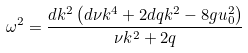<formula> <loc_0><loc_0><loc_500><loc_500>\omega ^ { 2 } = \frac { { d { k ^ { 2 } } \left ( { d \nu { k ^ { 4 } } + 2 d q { k ^ { 2 } } - 8 g u _ { 0 } ^ { 2 } } \right ) } } { { \nu { k ^ { 2 } } + 2 q } }</formula> 